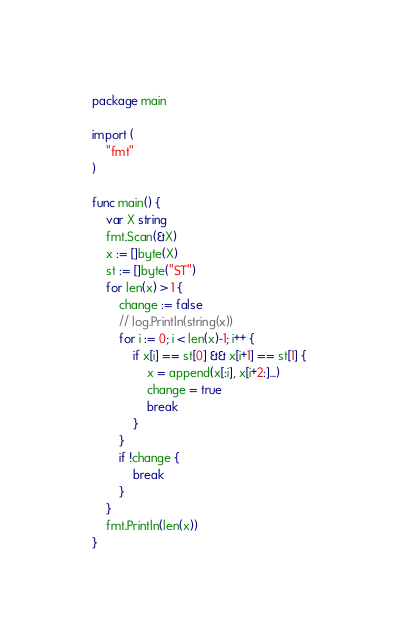Convert code to text. <code><loc_0><loc_0><loc_500><loc_500><_Go_>package main

import (
	"fmt"
)

func main() {
	var X string
	fmt.Scan(&X)
	x := []byte(X)
	st := []byte("ST")
	for len(x) > 1 {
		change := false
		// log.Println(string(x))
		for i := 0; i < len(x)-1; i++ {
			if x[i] == st[0] && x[i+1] == st[1] {
				x = append(x[:i], x[i+2:]...)
				change = true
				break
			}
		}
		if !change {
			break
		}
	}
	fmt.Println(len(x))
}
</code> 